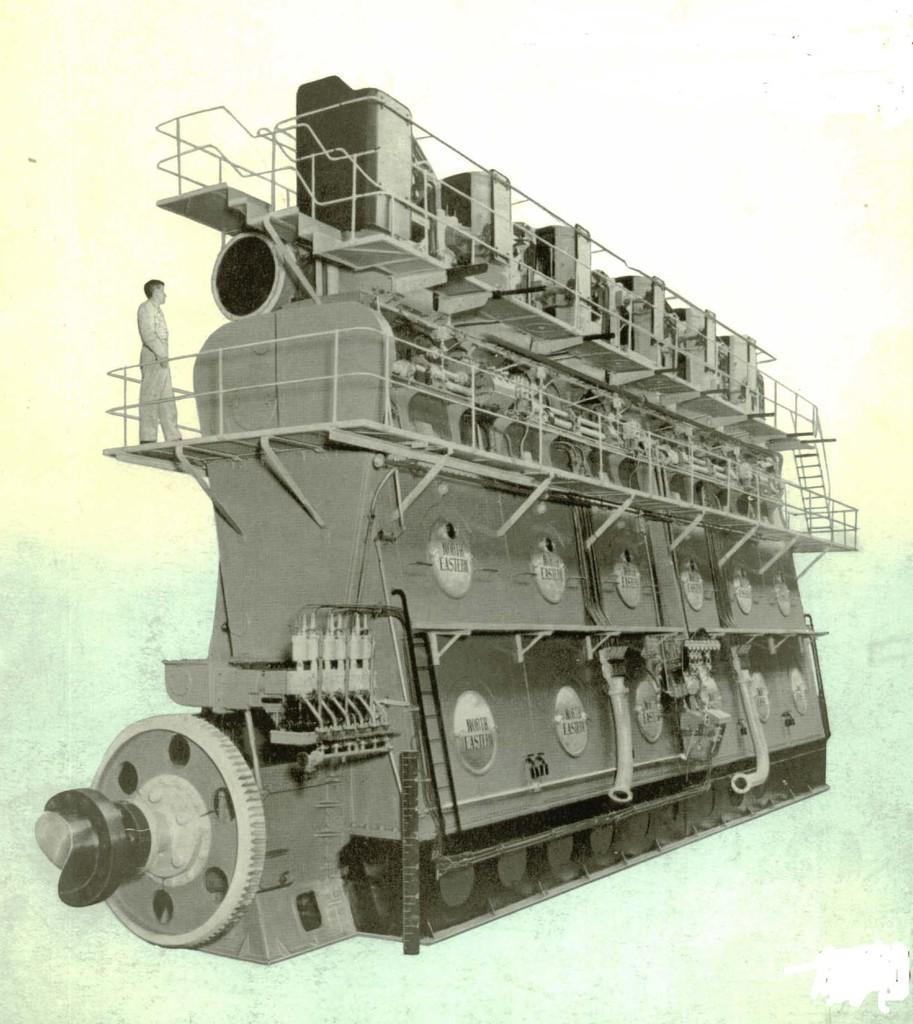What type of ship is depicted in the image? There is a picture of an escort carrier in the image. Can you describe any other elements in the image besides the escort carrier? Yes, there is a person standing on the escort carrier in the image. What type of quilt is being used to twist around the person on the escort carrier in the image? There is no quilt or any twisting action visible in the image. 